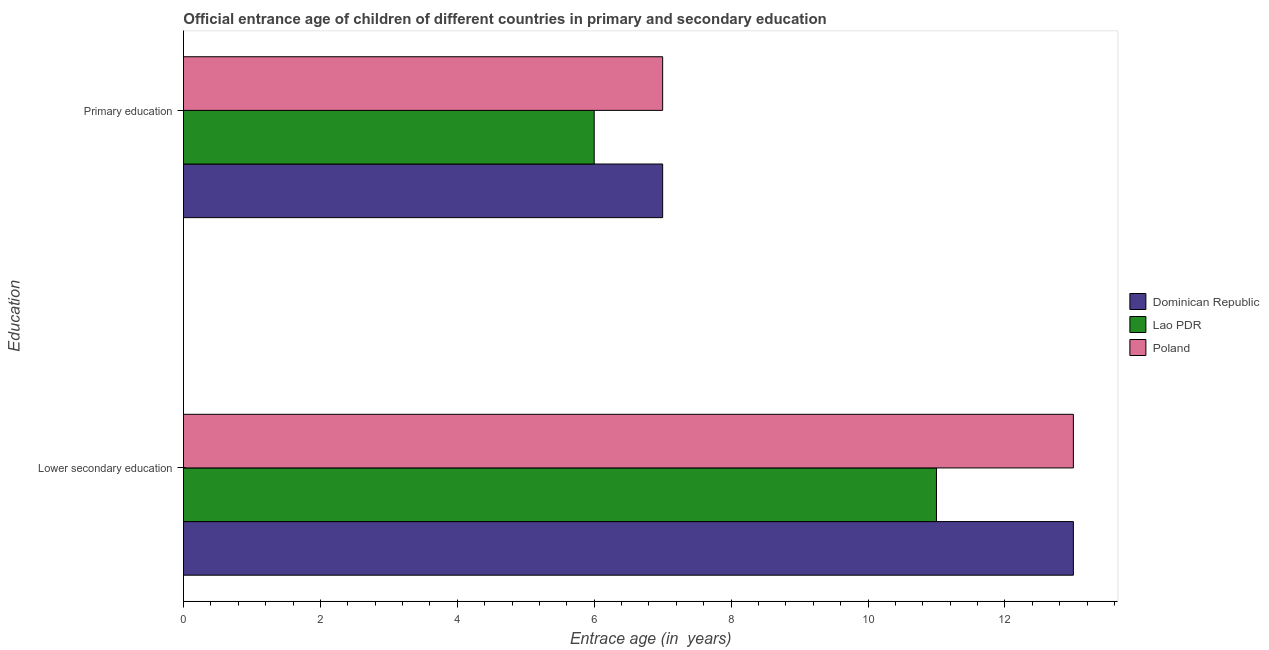How many different coloured bars are there?
Give a very brief answer. 3. How many groups of bars are there?
Offer a very short reply. 2. Are the number of bars on each tick of the Y-axis equal?
Keep it short and to the point. Yes. What is the label of the 1st group of bars from the top?
Offer a very short reply. Primary education. Across all countries, what is the maximum entrance age of chiildren in primary education?
Keep it short and to the point. 7. Across all countries, what is the minimum entrance age of children in lower secondary education?
Provide a short and direct response. 11. In which country was the entrance age of children in lower secondary education maximum?
Provide a short and direct response. Dominican Republic. In which country was the entrance age of chiildren in primary education minimum?
Your response must be concise. Lao PDR. What is the total entrance age of chiildren in primary education in the graph?
Keep it short and to the point. 20. What is the difference between the entrance age of chiildren in primary education in Dominican Republic and that in Lao PDR?
Make the answer very short. 1. What is the difference between the entrance age of children in lower secondary education in Lao PDR and the entrance age of chiildren in primary education in Poland?
Your answer should be very brief. 4. What is the average entrance age of children in lower secondary education per country?
Provide a short and direct response. 12.33. What is the ratio of the entrance age of children in lower secondary education in Lao PDR to that in Poland?
Your answer should be compact. 0.85. Is the entrance age of children in lower secondary education in Dominican Republic less than that in Lao PDR?
Your response must be concise. No. In how many countries, is the entrance age of children in lower secondary education greater than the average entrance age of children in lower secondary education taken over all countries?
Make the answer very short. 2. What does the 2nd bar from the top in Lower secondary education represents?
Give a very brief answer. Lao PDR. What does the 2nd bar from the bottom in Lower secondary education represents?
Provide a succinct answer. Lao PDR. Are all the bars in the graph horizontal?
Provide a short and direct response. Yes. How many countries are there in the graph?
Make the answer very short. 3. Does the graph contain any zero values?
Your response must be concise. No. Does the graph contain grids?
Keep it short and to the point. No. What is the title of the graph?
Provide a succinct answer. Official entrance age of children of different countries in primary and secondary education. What is the label or title of the X-axis?
Provide a short and direct response. Entrace age (in  years). What is the label or title of the Y-axis?
Your response must be concise. Education. What is the Entrace age (in  years) of Dominican Republic in Lower secondary education?
Your answer should be very brief. 13. What is the Entrace age (in  years) of Lao PDR in Lower secondary education?
Provide a short and direct response. 11. What is the Entrace age (in  years) of Dominican Republic in Primary education?
Give a very brief answer. 7. Across all Education, what is the minimum Entrace age (in  years) in Lao PDR?
Provide a succinct answer. 6. Across all Education, what is the minimum Entrace age (in  years) in Poland?
Your answer should be very brief. 7. What is the total Entrace age (in  years) of Lao PDR in the graph?
Keep it short and to the point. 17. What is the difference between the Entrace age (in  years) in Lao PDR in Lower secondary education and that in Primary education?
Your response must be concise. 5. What is the difference between the Entrace age (in  years) of Poland in Lower secondary education and that in Primary education?
Ensure brevity in your answer.  6. What is the difference between the Entrace age (in  years) of Dominican Republic in Lower secondary education and the Entrace age (in  years) of Lao PDR in Primary education?
Provide a succinct answer. 7. What is the average Entrace age (in  years) in Dominican Republic per Education?
Offer a very short reply. 10. What is the average Entrace age (in  years) in Poland per Education?
Your answer should be compact. 10. What is the difference between the Entrace age (in  years) in Dominican Republic and Entrace age (in  years) in Lao PDR in Lower secondary education?
Your response must be concise. 2. What is the difference between the Entrace age (in  years) in Dominican Republic and Entrace age (in  years) in Poland in Lower secondary education?
Your answer should be very brief. 0. What is the difference between the Entrace age (in  years) in Dominican Republic and Entrace age (in  years) in Poland in Primary education?
Offer a terse response. 0. What is the ratio of the Entrace age (in  years) of Dominican Republic in Lower secondary education to that in Primary education?
Your answer should be very brief. 1.86. What is the ratio of the Entrace age (in  years) of Lao PDR in Lower secondary education to that in Primary education?
Offer a very short reply. 1.83. What is the ratio of the Entrace age (in  years) in Poland in Lower secondary education to that in Primary education?
Offer a terse response. 1.86. What is the difference between the highest and the second highest Entrace age (in  years) in Dominican Republic?
Offer a very short reply. 6. 